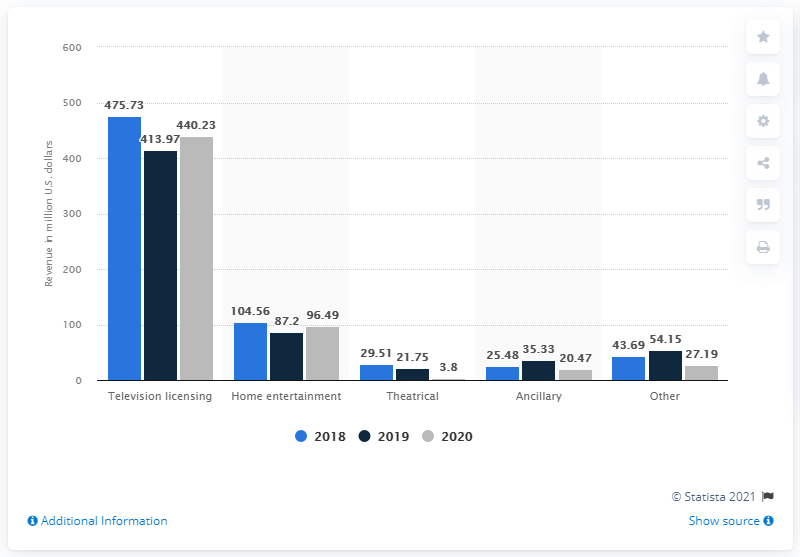Outline some significant characteristics in this image. In 2020, MGM Holdings reported $3.8 billion in theatrical segment revenue for its film content department. 